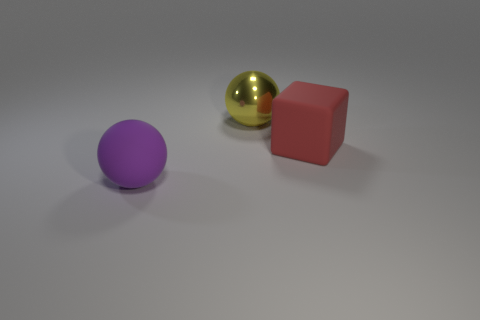Add 3 large spheres. How many objects exist? 6 Subtract all cubes. How many objects are left? 2 Subtract 0 blue cylinders. How many objects are left? 3 Subtract all shiny objects. Subtract all cubes. How many objects are left? 1 Add 2 big purple matte balls. How many big purple matte balls are left? 3 Add 1 yellow objects. How many yellow objects exist? 2 